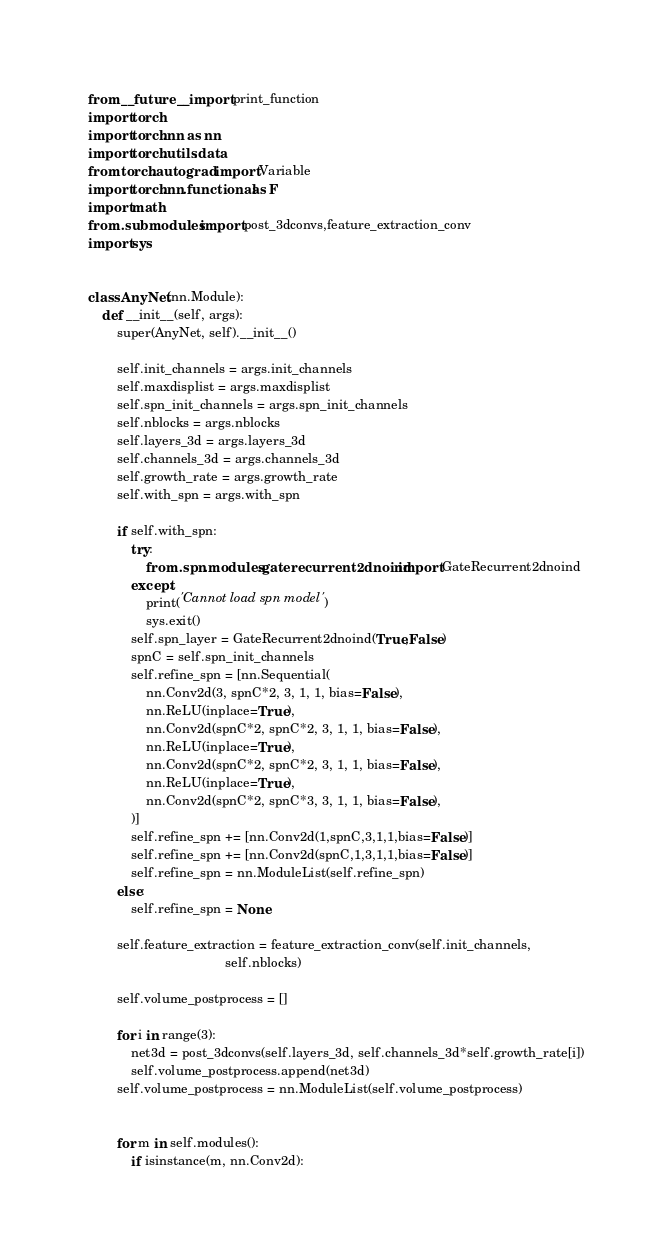<code> <loc_0><loc_0><loc_500><loc_500><_Python_>from __future__ import print_function
import torch
import torch.nn as nn
import torch.utils.data
from torch.autograd import Variable
import torch.nn.functional as F
import math
from .submodules import post_3dconvs,feature_extraction_conv
import sys


class AnyNet(nn.Module):
    def __init__(self, args):
        super(AnyNet, self).__init__()

        self.init_channels = args.init_channels
        self.maxdisplist = args.maxdisplist
        self.spn_init_channels = args.spn_init_channels
        self.nblocks = args.nblocks
        self.layers_3d = args.layers_3d
        self.channels_3d = args.channels_3d
        self.growth_rate = args.growth_rate
        self.with_spn = args.with_spn

        if self.with_spn:
            try:
                from .spn.modules.gaterecurrent2dnoind import GateRecurrent2dnoind
            except:
                print('Cannot load spn model')
                sys.exit()
            self.spn_layer = GateRecurrent2dnoind(True,False)
            spnC = self.spn_init_channels
            self.refine_spn = [nn.Sequential(
                nn.Conv2d(3, spnC*2, 3, 1, 1, bias=False),
                nn.ReLU(inplace=True),
                nn.Conv2d(spnC*2, spnC*2, 3, 1, 1, bias=False),
                nn.ReLU(inplace=True),
                nn.Conv2d(spnC*2, spnC*2, 3, 1, 1, bias=False),
                nn.ReLU(inplace=True),
                nn.Conv2d(spnC*2, spnC*3, 3, 1, 1, bias=False),
            )]
            self.refine_spn += [nn.Conv2d(1,spnC,3,1,1,bias=False)]
            self.refine_spn += [nn.Conv2d(spnC,1,3,1,1,bias=False)]
            self.refine_spn = nn.ModuleList(self.refine_spn)
        else:
            self.refine_spn = None

        self.feature_extraction = feature_extraction_conv(self.init_channels,
                                      self.nblocks)

        self.volume_postprocess = []

        for i in range(3):
            net3d = post_3dconvs(self.layers_3d, self.channels_3d*self.growth_rate[i])
            self.volume_postprocess.append(net3d)
        self.volume_postprocess = nn.ModuleList(self.volume_postprocess)


        for m in self.modules():
            if isinstance(m, nn.Conv2d):</code> 